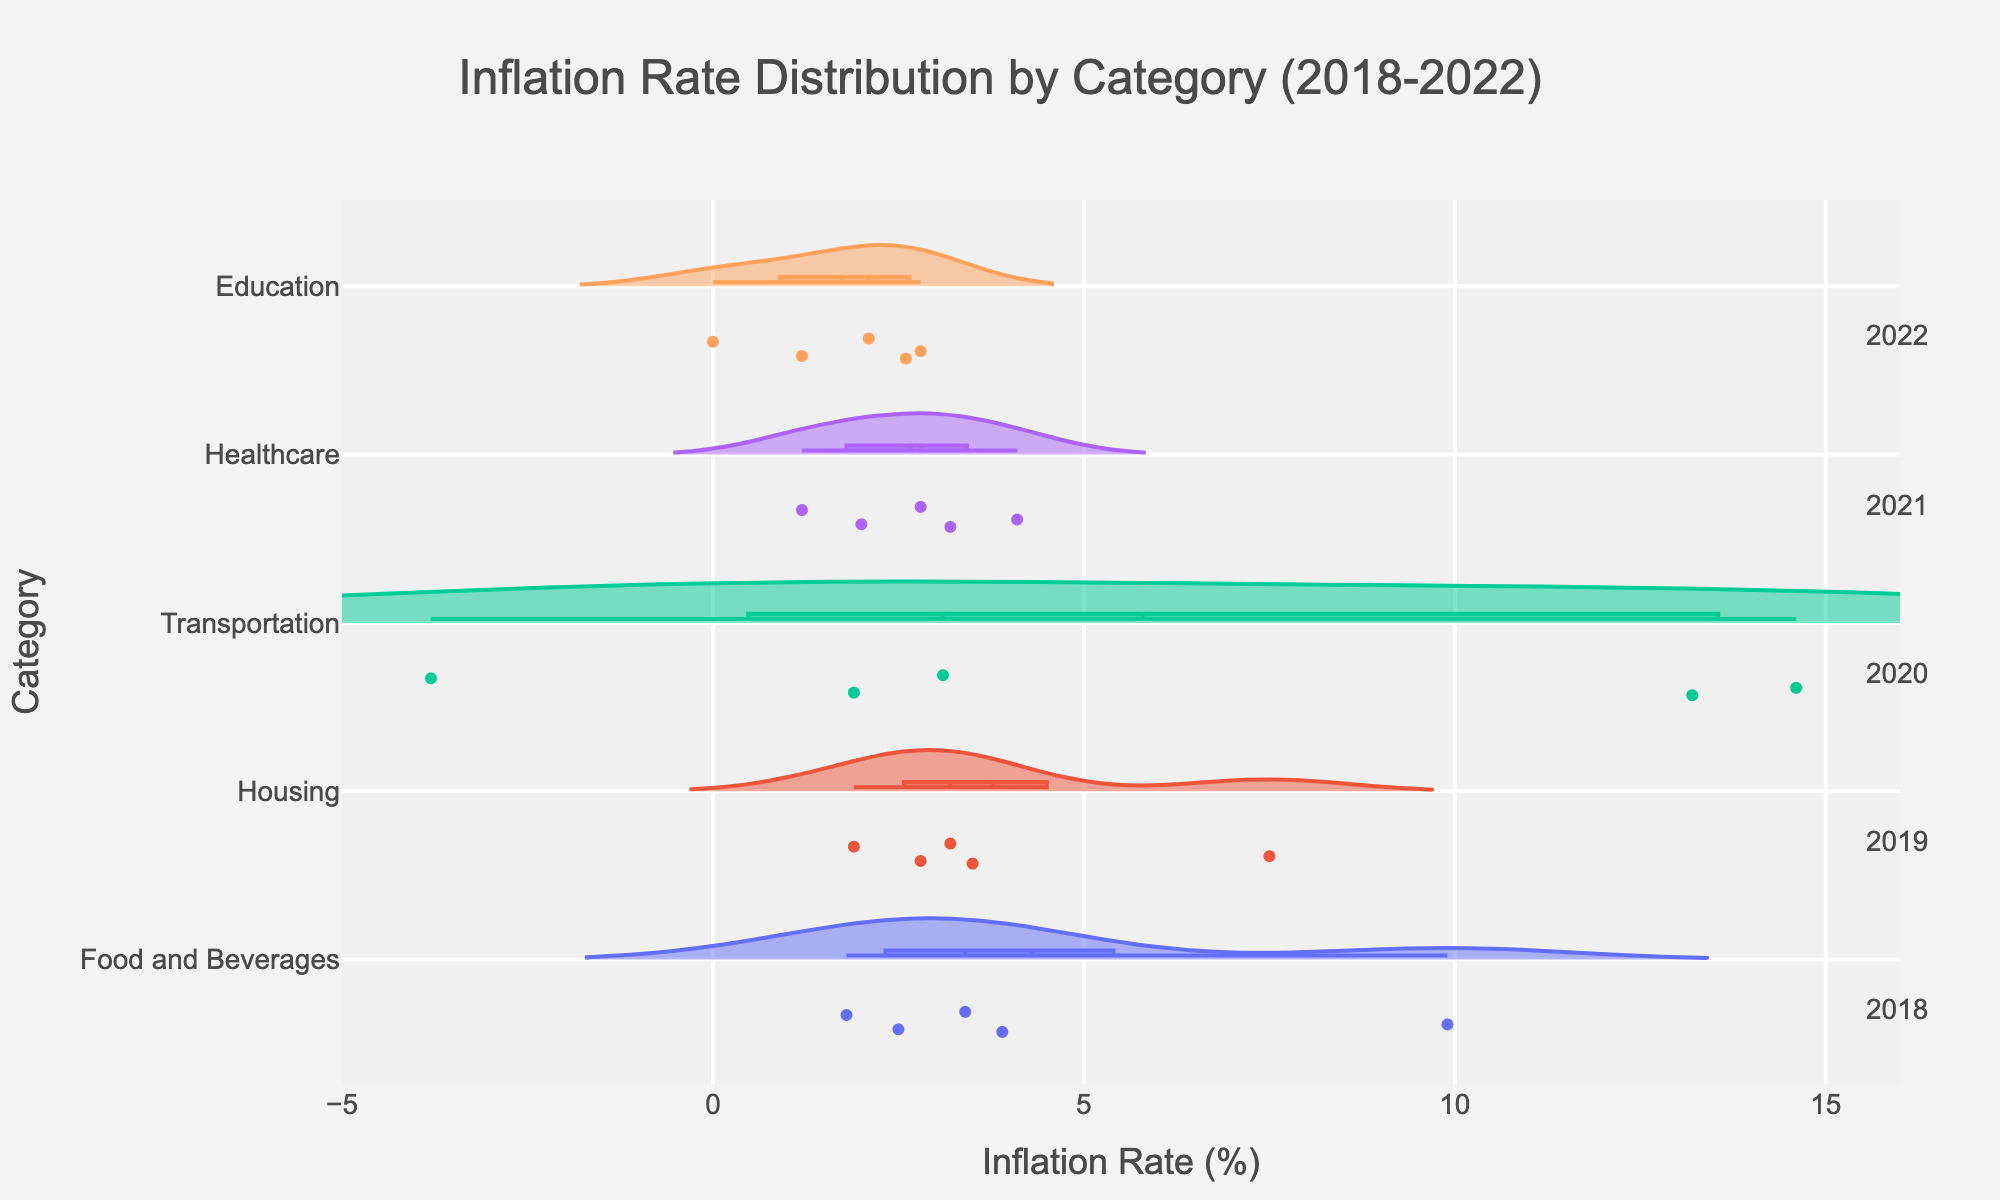What is the average inflation rate for the 'Food and Beverages' category? The inflation rates for 'Food and Beverages' from 2018 to 2022 are 2.5, 1.8, 3.4, 3.9, and 9.9. Summing them up gives 21.5. Dividing this by 5, the number of years, gives an average inflation rate of 4.3.
Answer: 4.3 Which category has the highest peak of inflation rate in 2021? In 2021, the 'Transportation' category has the highest peak of inflation rate at 13.2.
Answer: Transportation How does the inflation rate for 'Healthcare' in 2020 compare to its rate in 2021? In 2020, the inflation rate for 'Healthcare' was 4.1, while in 2021, it dropped to 1.2. Thus, the 2021 rate is lower than the 2020 rate.
Answer: Lower Which category had a negative inflation rate during the observed period? The 'Transportation' category had a negative inflation rate of -3.8 in 2020.
Answer: Transportation What is the range of inflation rates for the 'Housing' category? The 'Housing' inflation rates range from the lowest rate of 1.9 in 2020 to the highest rate of 7.5 in 2022, making the range 7.5 - 1.9 = 5.6.
Answer: 5.6 Which category showed the highest increase in inflation rate from 2020 to 2021? The 'Transportation' category increased from -3.8 in 2020 to 13.2 in 2021, showing an increase of 17.0, which is the highest increase among all categories.
Answer: Transportation What is the median inflation rate for 'Education' over the observed years? The 'Education' inflation rates from 2018 to 2022 are 2.6, 2.1, 1.2, 0.0, and 2.8. Sorting them gives 0.0, 1.2, 2.1, 2.6, 2.8. The median value is the middle one, 2.1.
Answer: 2.1 How many categories experienced their highest inflation rate in 2022? By observing the peaks in 2022, 'Food and Beverages' (9.9), 'Housing' (7.5), 'Transportation' (14.6), and 'Education' (2.8) experienced their highest inflation rates in 2022. So, 4 categories.
Answer: 4 Which category had the least variation in inflation rate over the observed years? The 'Education' category had the smallest difference between its highest and lowest values (2.8 - 0.0 = 2.8), showing the least variation in comparison to other categories.
Answer: Education 